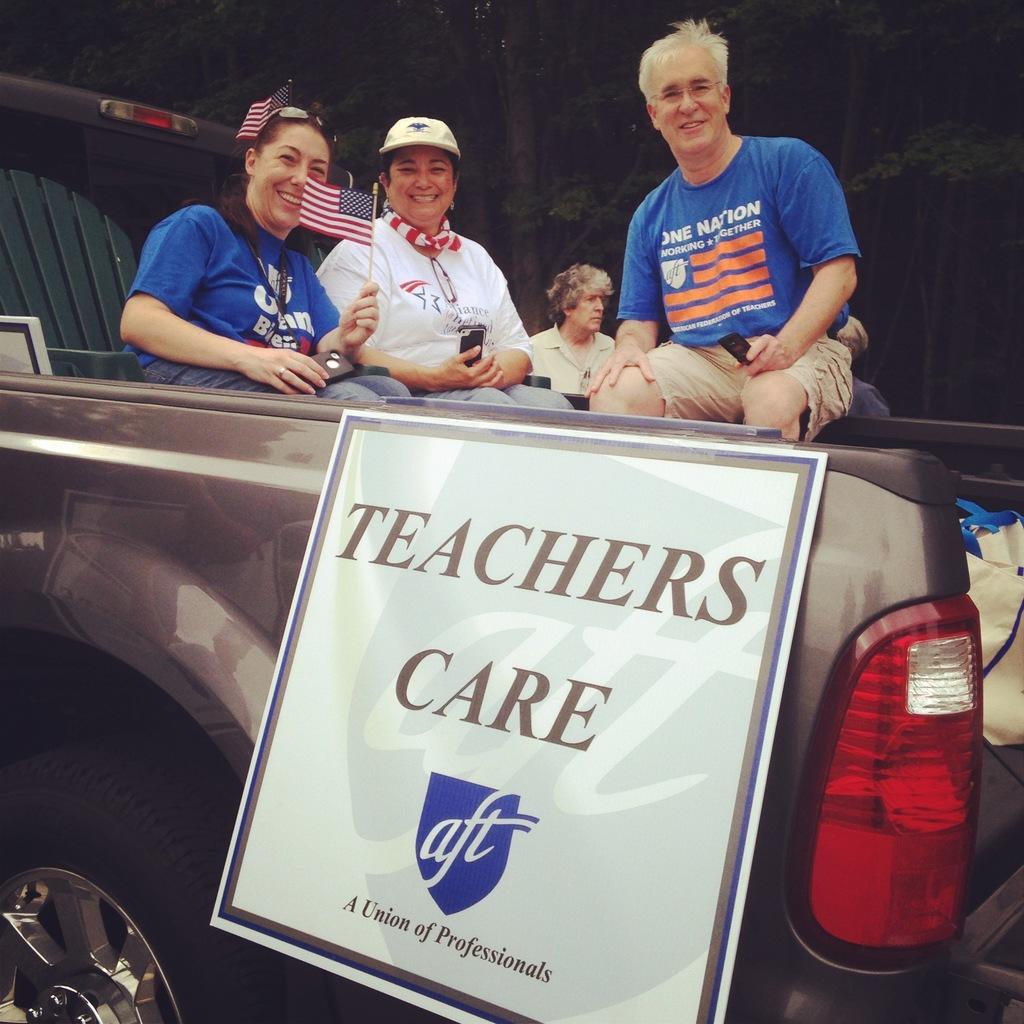Describe this image in one or two sentences. In this picture I can observe some people sitting in the vehicle. It is looking like a jeep. I can observe a board on the vehicle. In the background there are trees. 